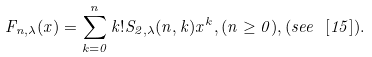Convert formula to latex. <formula><loc_0><loc_0><loc_500><loc_500>F _ { n , \lambda } ( x ) = \sum _ { k = 0 } ^ { n } k ! S _ { 2 , \lambda } ( n , k ) x ^ { k } , ( n \geq 0 ) , ( s e e \ [ 1 5 ] ) .</formula> 